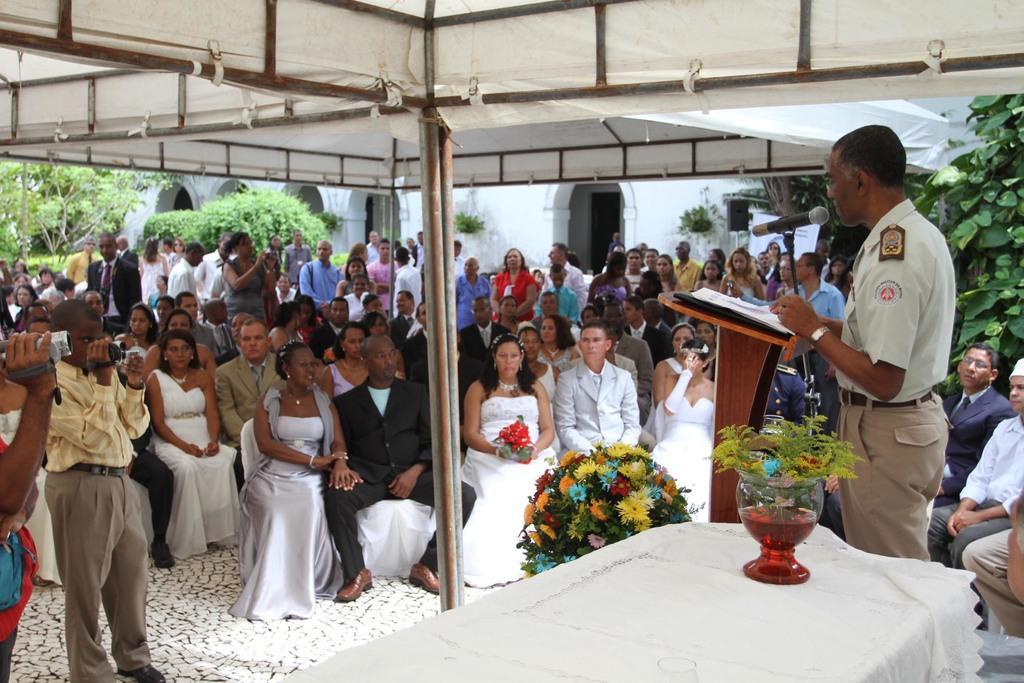In one or two sentences, can you explain what this image depicts? In this image, we can see a group of people. Few are sitting and standing. Here we can see table covered with cloth, flower vase, plants, wall, rods. Right side of the image, a person is standing near the podium. Here there is a microphone and rod. Left side of the image, we can see few people are holding cameras. Top of the image, we can see tents. 